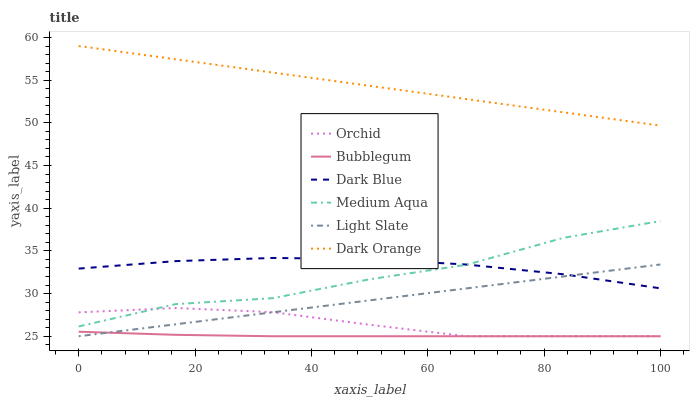Does Bubblegum have the minimum area under the curve?
Answer yes or no. Yes. Does Dark Orange have the maximum area under the curve?
Answer yes or no. Yes. Does Light Slate have the minimum area under the curve?
Answer yes or no. No. Does Light Slate have the maximum area under the curve?
Answer yes or no. No. Is Light Slate the smoothest?
Answer yes or no. Yes. Is Medium Aqua the roughest?
Answer yes or no. Yes. Is Bubblegum the smoothest?
Answer yes or no. No. Is Bubblegum the roughest?
Answer yes or no. No. Does Dark Blue have the lowest value?
Answer yes or no. No. Does Dark Orange have the highest value?
Answer yes or no. Yes. Does Light Slate have the highest value?
Answer yes or no. No. Is Light Slate less than Medium Aqua?
Answer yes or no. Yes. Is Dark Blue greater than Bubblegum?
Answer yes or no. Yes. Does Light Slate intersect Medium Aqua?
Answer yes or no. No. 